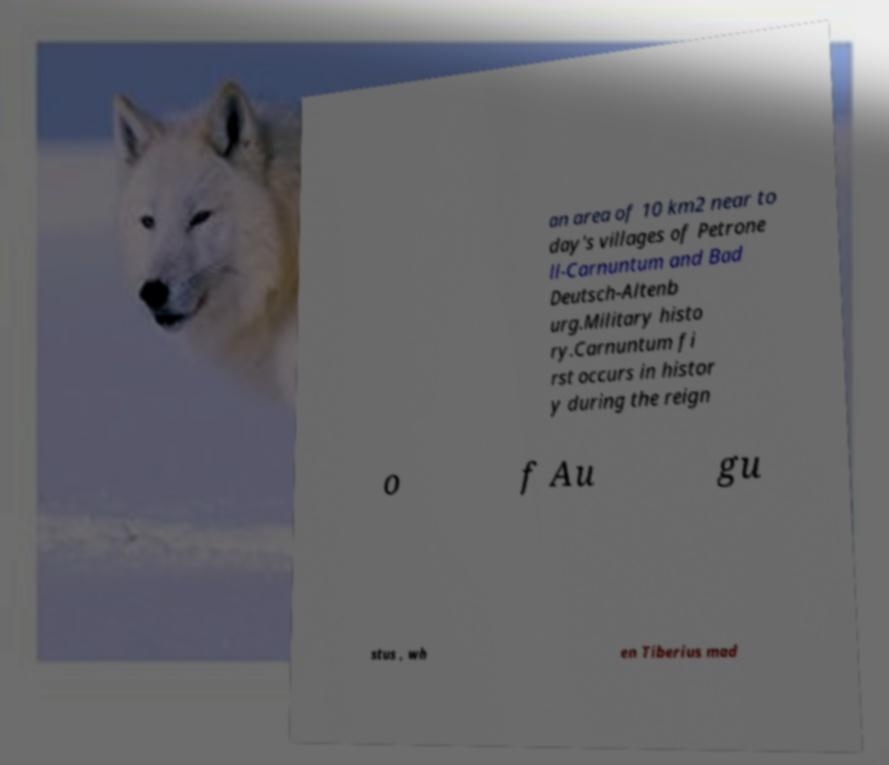I need the written content from this picture converted into text. Can you do that? an area of 10 km2 near to day's villages of Petrone ll-Carnuntum and Bad Deutsch-Altenb urg.Military histo ry.Carnuntum fi rst occurs in histor y during the reign o f Au gu stus , wh en Tiberius mad 